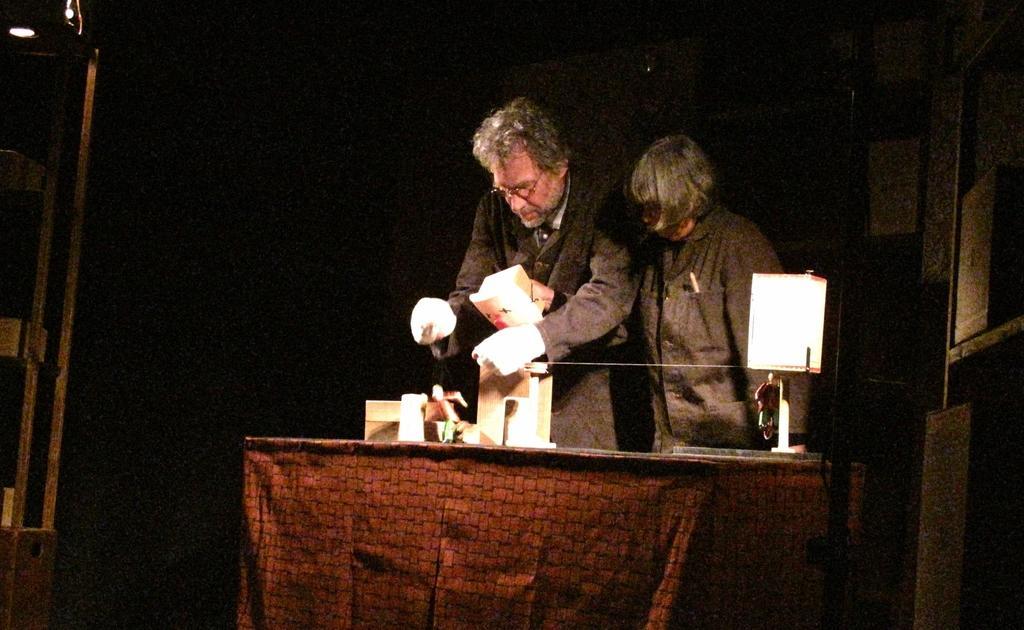Please provide a concise description of this image. In this image I can see two persons wearing black dress are standing in front of a table and on the table I can see a lamp and few other objects and I can see the dark background. 